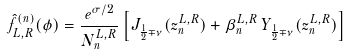Convert formula to latex. <formula><loc_0><loc_0><loc_500><loc_500>\hat { f } ^ { ( n ) } _ { L , R } ( \phi ) = \frac { e ^ { \sigma / 2 } } { N _ { n } ^ { L , R } } \left [ J _ { \frac { 1 } { 2 } \mp \nu } ( z _ { n } ^ { L , R } ) + \beta _ { n } ^ { L , R } \, Y _ { \frac { 1 } { 2 } \mp \nu } ( z _ { n } ^ { L , R } ) \right ]</formula> 